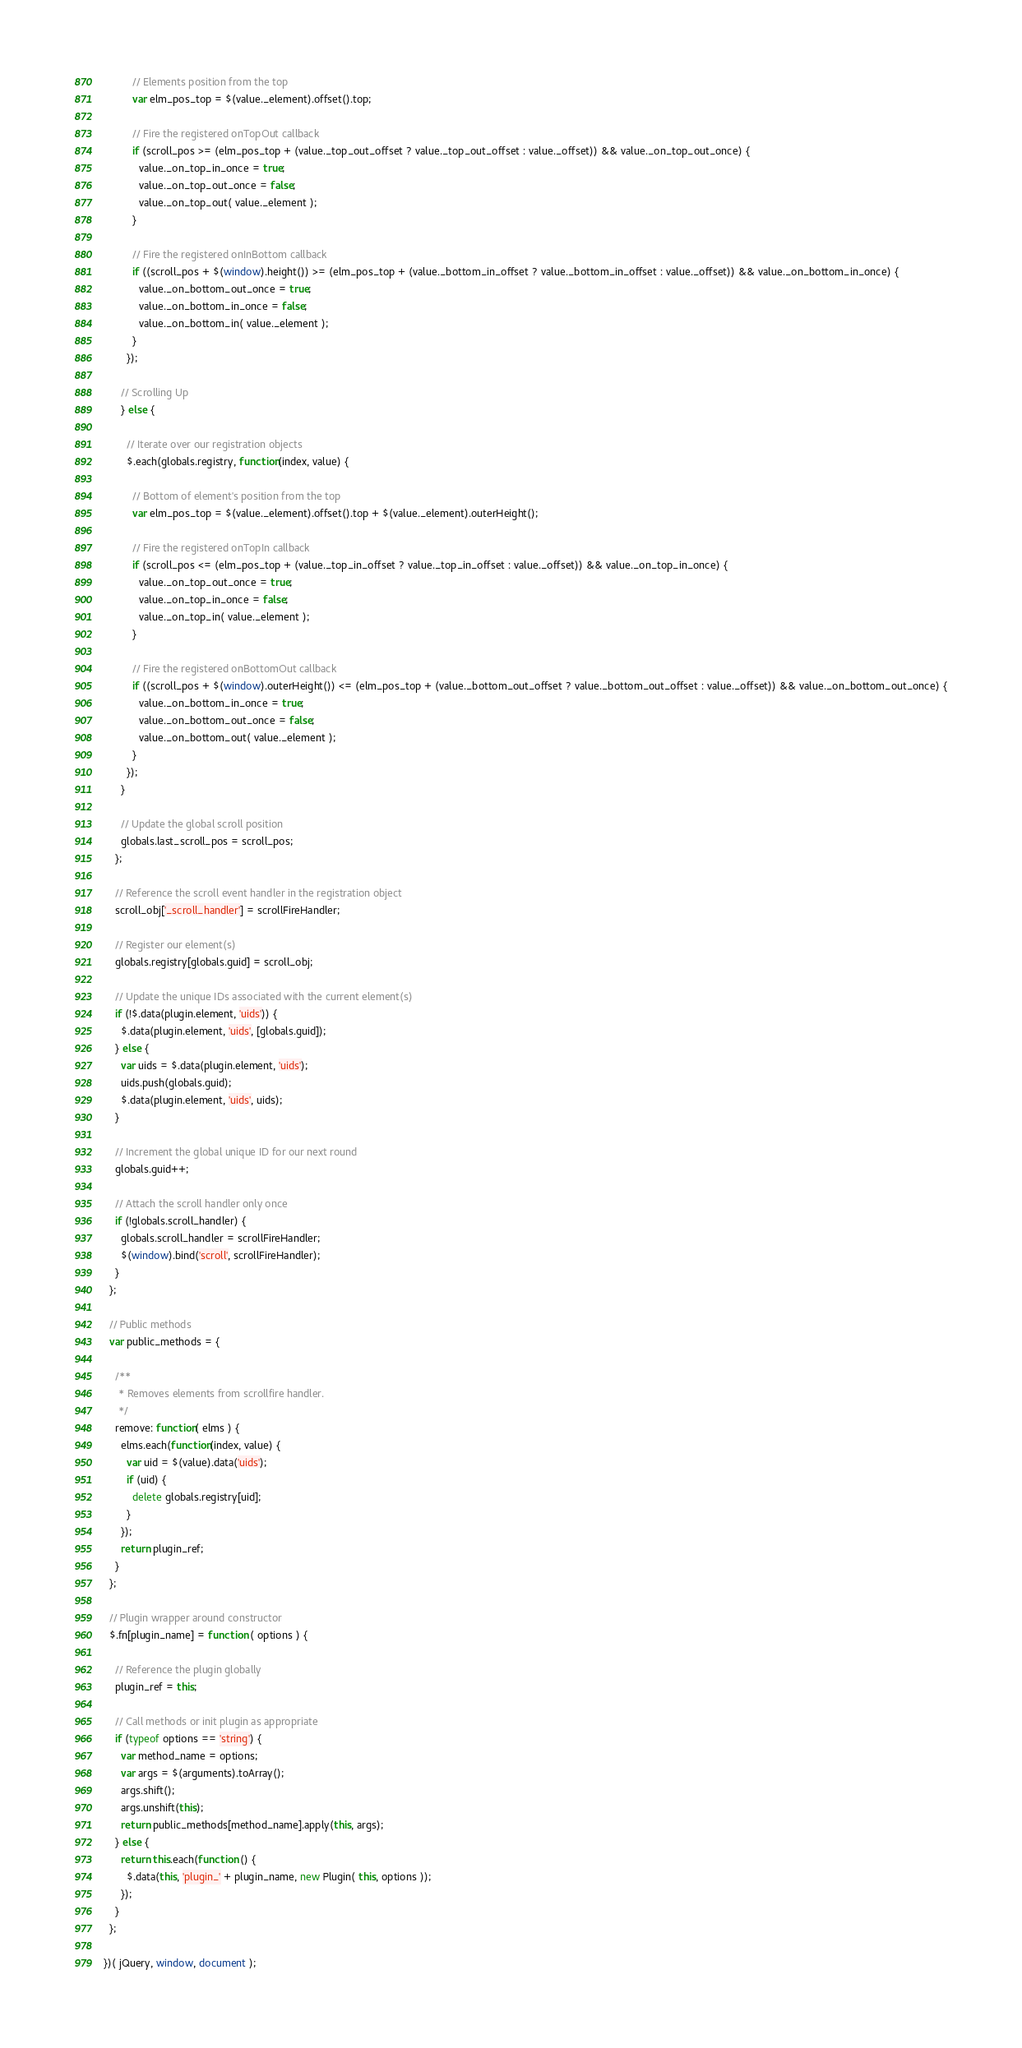<code> <loc_0><loc_0><loc_500><loc_500><_JavaScript_>
          // Elements position from the top
          var elm_pos_top = $(value._element).offset().top;

          // Fire the registered onTopOut callback
          if (scroll_pos >= (elm_pos_top + (value._top_out_offset ? value._top_out_offset : value._offset)) && value._on_top_out_once) {
            value._on_top_in_once = true;
            value._on_top_out_once = false;
            value._on_top_out( value._element );
          }

          // Fire the registered onInBottom callback
          if ((scroll_pos + $(window).height()) >= (elm_pos_top + (value._bottom_in_offset ? value._bottom_in_offset : value._offset)) && value._on_bottom_in_once) {
            value._on_bottom_out_once = true;
            value._on_bottom_in_once = false;
            value._on_bottom_in( value._element );
          }
        });

      // Scrolling Up
      } else {

        // Iterate over our registration objects
        $.each(globals.registry, function(index, value) {

          // Bottom of element's position from the top
          var elm_pos_top = $(value._element).offset().top + $(value._element).outerHeight();

          // Fire the registered onTopIn callback
          if (scroll_pos <= (elm_pos_top + (value._top_in_offset ? value._top_in_offset : value._offset)) && value._on_top_in_once) {
            value._on_top_out_once = true;
            value._on_top_in_once = false;
            value._on_top_in( value._element );
          }

          // Fire the registered onBottomOut callback
          if ((scroll_pos + $(window).outerHeight()) <= (elm_pos_top + (value._bottom_out_offset ? value._bottom_out_offset : value._offset)) && value._on_bottom_out_once) {
            value._on_bottom_in_once = true;
            value._on_bottom_out_once = false;
            value._on_bottom_out( value._element );
          }
        });
      }

      // Update the global scroll position
      globals.last_scroll_pos = scroll_pos;
    };

    // Reference the scroll event handler in the registration object
    scroll_obj['_scroll_handler'] = scrollFireHandler;

    // Register our element(s)
    globals.registry[globals.guid] = scroll_obj;

    // Update the unique IDs associated with the current element(s)
    if (!$.data(plugin.element, 'uids')) {
      $.data(plugin.element, 'uids', [globals.guid]);
    } else {
      var uids = $.data(plugin.element, 'uids');
      uids.push(globals.guid);
      $.data(plugin.element, 'uids', uids);
    }

    // Increment the global unique ID for our next round
    globals.guid++;

    // Attach the scroll handler only once
    if (!globals.scroll_handler) {
      globals.scroll_handler = scrollFireHandler;
      $(window).bind('scroll', scrollFireHandler);
    }
  };

  // Public methods
  var public_methods = {

    /**
     * Removes elements from scrollfire handler.
     */
    remove: function( elms ) {
      elms.each(function(index, value) {
        var uid = $(value).data('uids');
        if (uid) {
          delete globals.registry[uid];
        }
      });
      return plugin_ref;
    }
  };

  // Plugin wrapper around constructor
  $.fn[plugin_name] = function ( options ) {

    // Reference the plugin globally
    plugin_ref = this;

    // Call methods or init plugin as appropriate
    if (typeof options == 'string') {
      var method_name = options;
      var args = $(arguments).toArray();
      args.shift();
      args.unshift(this);
      return public_methods[method_name].apply(this, args);
    } else {
      return this.each(function () {
        $.data(this, 'plugin_' + plugin_name, new Plugin( this, options ));
      });
    }
  };

})( jQuery, window, document );</code> 